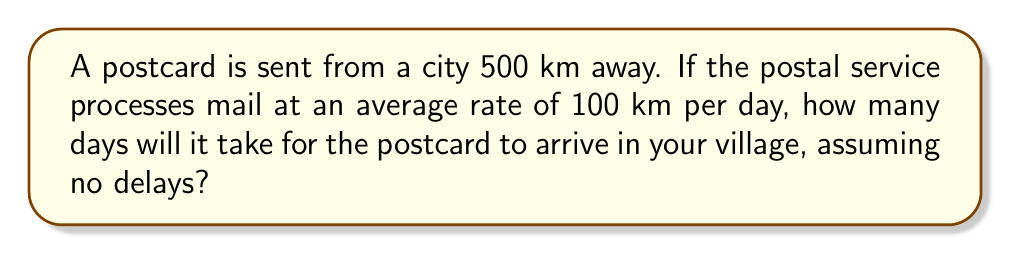What is the answer to this math problem? To solve this problem, we need to use the formula for time, given distance and rate:

$$\text{Time} = \frac{\text{Distance}}{\text{Rate}}$$

Let's plug in our known values:
- Distance: 500 km
- Rate: 100 km per day

$$\text{Time} = \frac{500 \text{ km}}{100 \text{ km/day}}$$

Simplifying:

$$\text{Time} = 5 \text{ days}$$

Therefore, under ideal conditions with no delays, it would take 5 days for the postcard to arrive in your village.
Answer: 5 days 